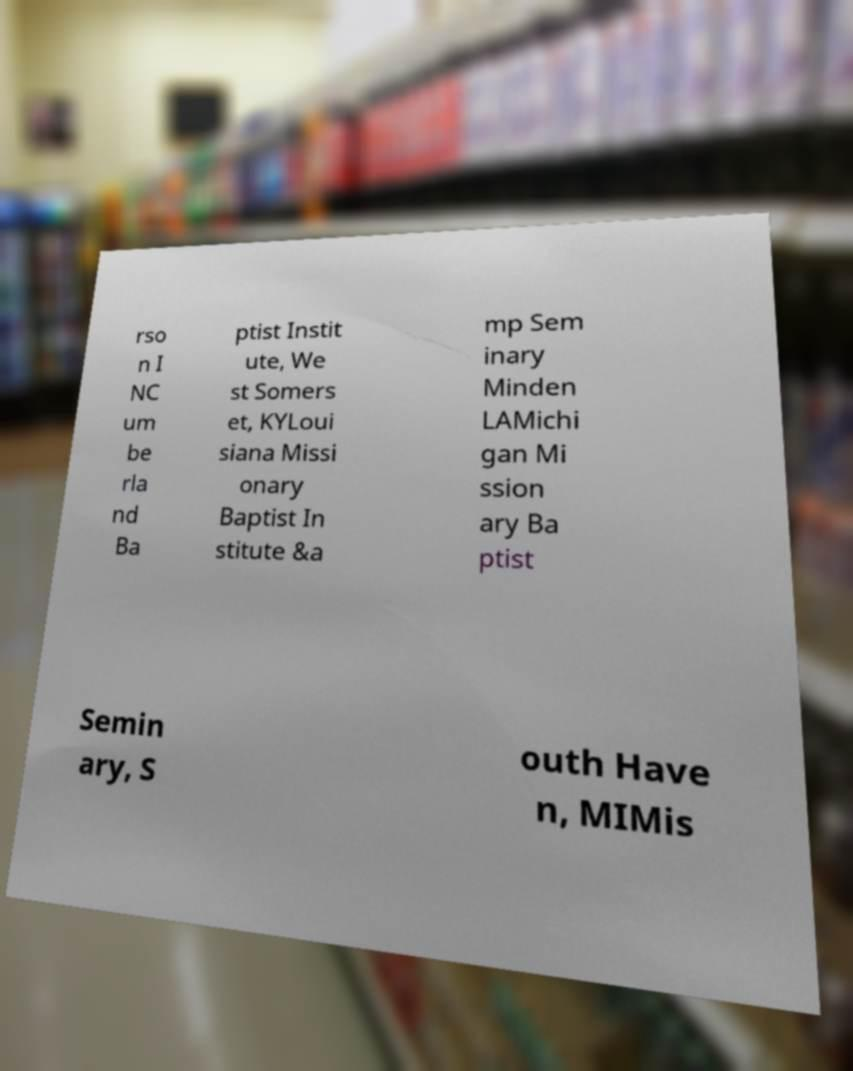Please read and relay the text visible in this image. What does it say? rso n I NC um be rla nd Ba ptist Instit ute, We st Somers et, KYLoui siana Missi onary Baptist In stitute &a mp Sem inary Minden LAMichi gan Mi ssion ary Ba ptist Semin ary, S outh Have n, MIMis 